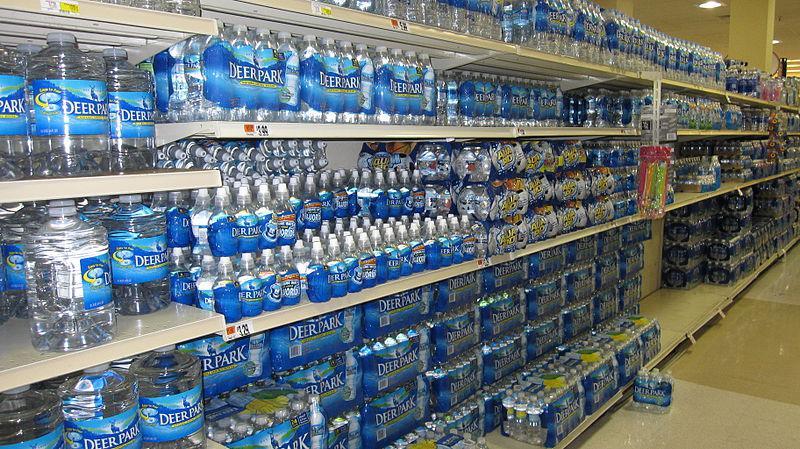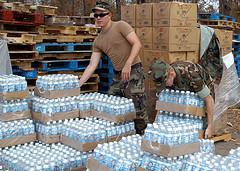The first image is the image on the left, the second image is the image on the right. Considering the images on both sides, is "There are at least two people in the image on the right." valid? Answer yes or no. Yes. 